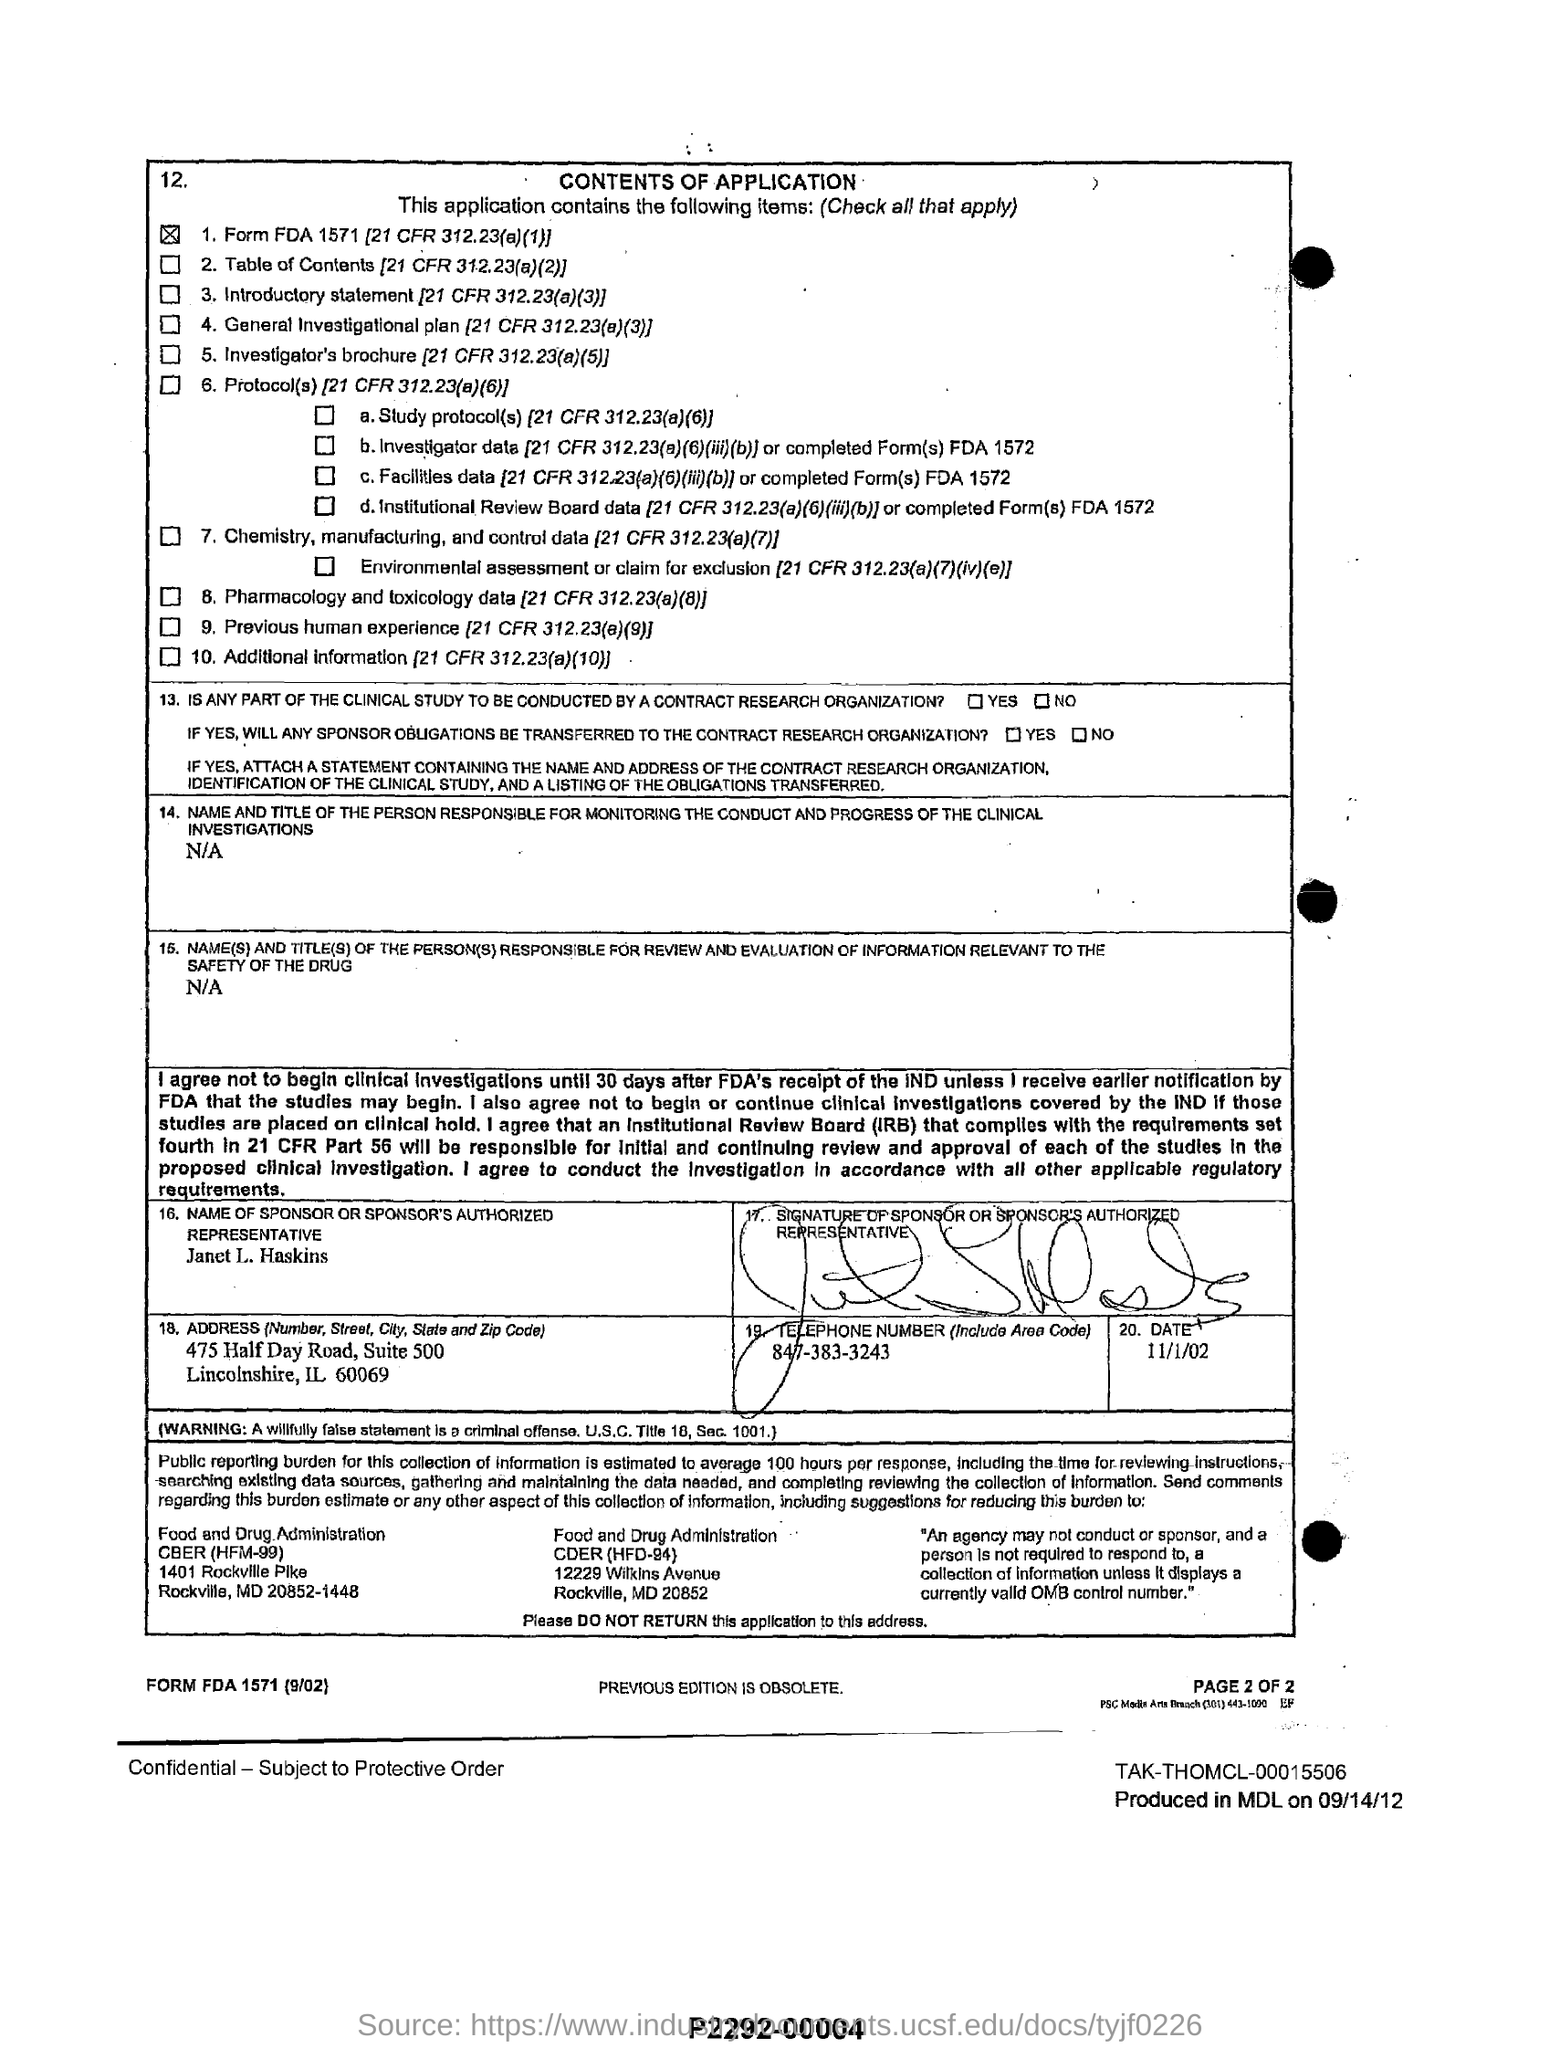What is the name of the sponsor or sponsor's authorized representative given in the application?
Offer a terse response. Janet L. Haskins. What is the telephone no of Janet L. Haskins?
Keep it short and to the point. 847-383-3243. 